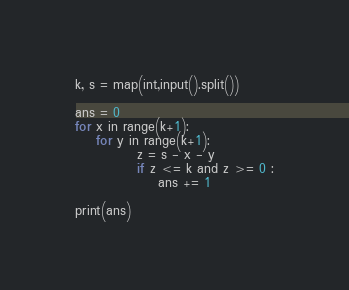<code> <loc_0><loc_0><loc_500><loc_500><_Python_>k, s = map(int,input().split())

ans = 0
for x in range(k+1):
    for y in range(k+1):
            z = s - x - y 
            if z <= k and z >= 0 :
                ans += 1

print(ans)</code> 